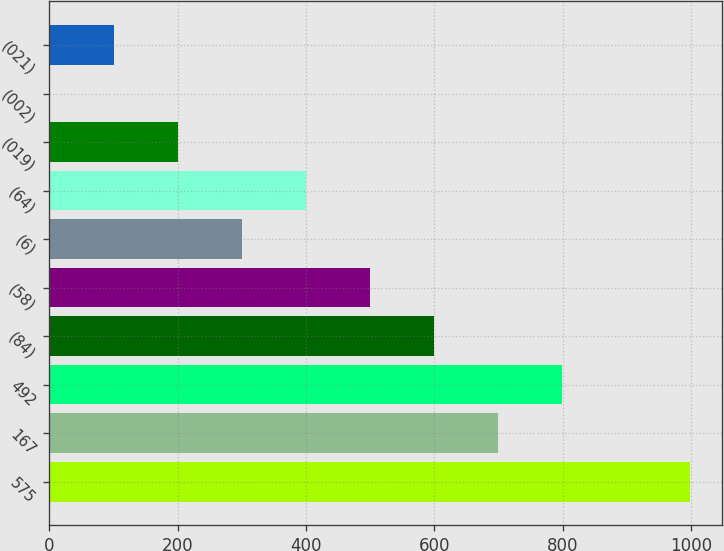<chart> <loc_0><loc_0><loc_500><loc_500><bar_chart><fcel>575<fcel>167<fcel>492<fcel>(84)<fcel>(58)<fcel>(6)<fcel>(64)<fcel>(019)<fcel>(002)<fcel>(021)<nl><fcel>999<fcel>699.31<fcel>799.21<fcel>599.41<fcel>499.51<fcel>299.71<fcel>399.61<fcel>199.81<fcel>0.01<fcel>99.91<nl></chart> 